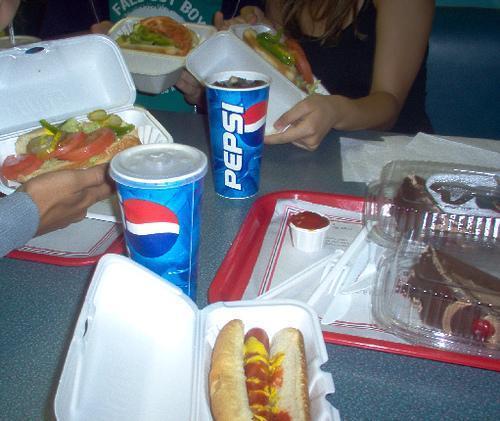How many hot dogs are seen?
Give a very brief answer. 1. How many hot dogs can be seen?
Give a very brief answer. 2. How many people are there?
Give a very brief answer. 2. How many cakes are visible?
Give a very brief answer. 2. How many cups can be seen?
Give a very brief answer. 3. How many sandwiches are in the photo?
Give a very brief answer. 2. How many bikes are there?
Give a very brief answer. 0. 